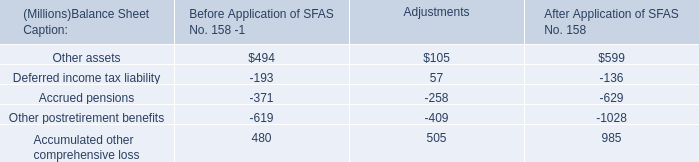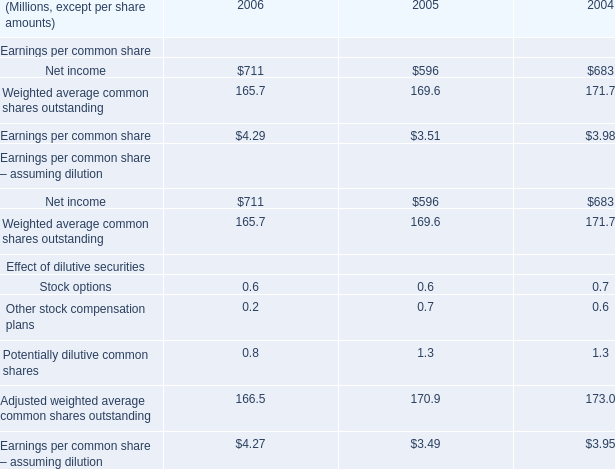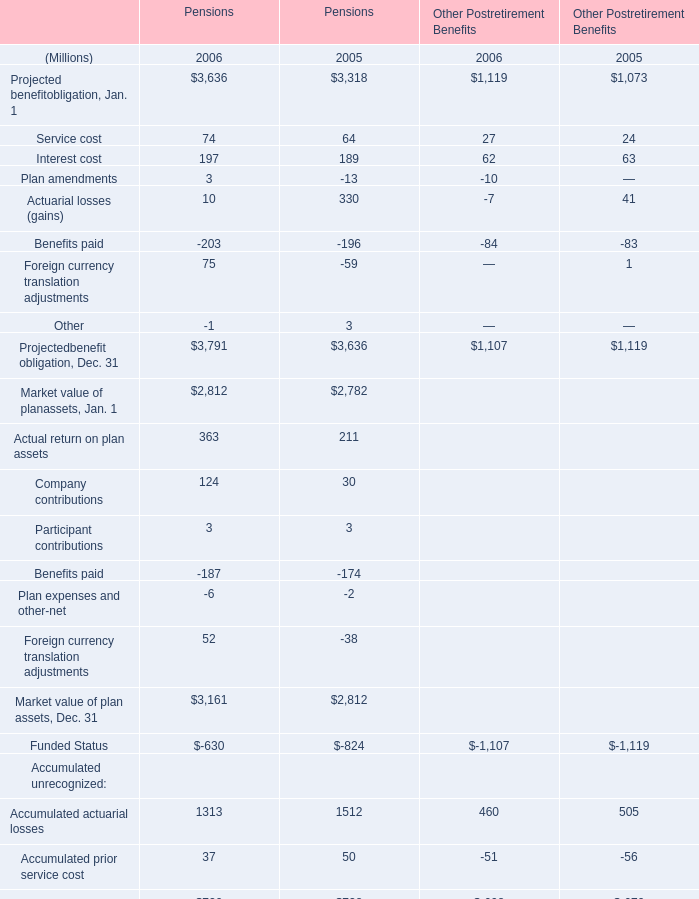what was the increase in asset retirement obligations for closure of assets in the chemicals manufacturing process in 2006? 
Computations: (10 / 9)
Answer: 1.11111. 